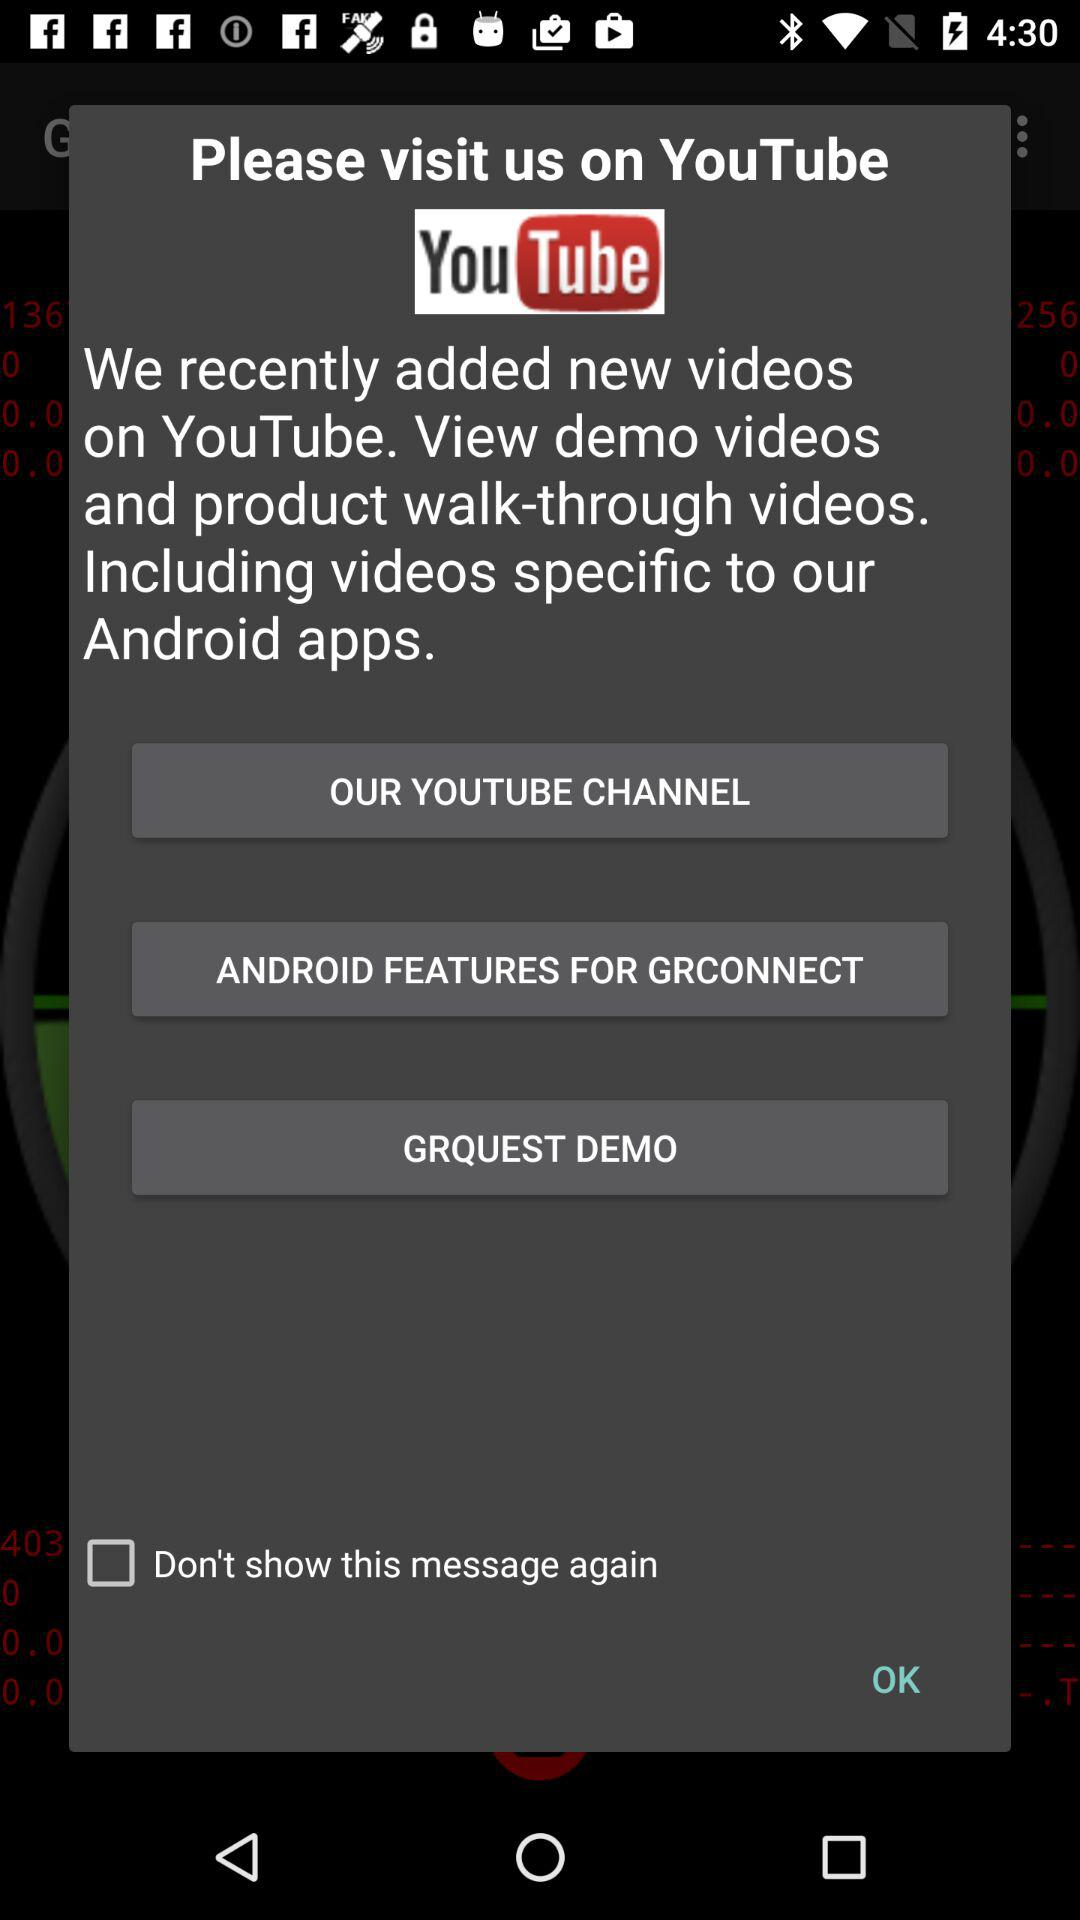What is the app's name? The app's name is "YouTube". 